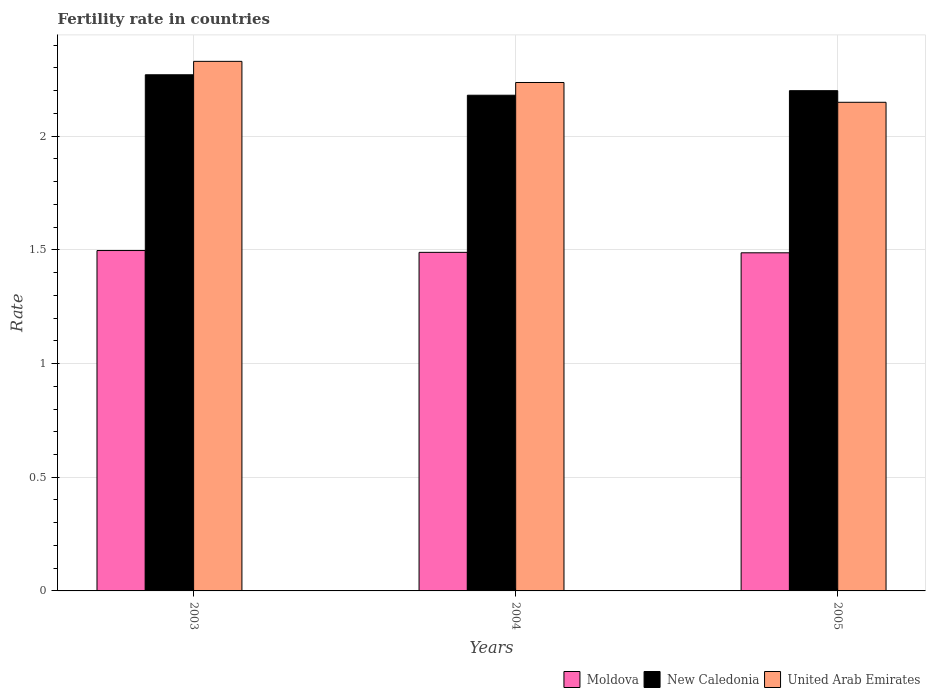Are the number of bars per tick equal to the number of legend labels?
Make the answer very short. Yes. How many bars are there on the 1st tick from the left?
Your answer should be compact. 3. In how many cases, is the number of bars for a given year not equal to the number of legend labels?
Offer a terse response. 0. What is the fertility rate in United Arab Emirates in 2005?
Make the answer very short. 2.15. Across all years, what is the maximum fertility rate in New Caledonia?
Make the answer very short. 2.27. Across all years, what is the minimum fertility rate in Moldova?
Your response must be concise. 1.49. In which year was the fertility rate in Moldova maximum?
Your response must be concise. 2003. In which year was the fertility rate in Moldova minimum?
Your response must be concise. 2005. What is the total fertility rate in United Arab Emirates in the graph?
Your answer should be very brief. 6.71. What is the difference between the fertility rate in New Caledonia in 2004 and that in 2005?
Your response must be concise. -0.02. What is the difference between the fertility rate in United Arab Emirates in 2003 and the fertility rate in Moldova in 2004?
Make the answer very short. 0.84. What is the average fertility rate in Moldova per year?
Provide a short and direct response. 1.49. In the year 2004, what is the difference between the fertility rate in Moldova and fertility rate in United Arab Emirates?
Provide a succinct answer. -0.75. In how many years, is the fertility rate in New Caledonia greater than 2.1?
Ensure brevity in your answer.  3. What is the ratio of the fertility rate in Moldova in 2004 to that in 2005?
Your answer should be very brief. 1. Is the fertility rate in United Arab Emirates in 2003 less than that in 2005?
Your answer should be very brief. No. What is the difference between the highest and the second highest fertility rate in New Caledonia?
Offer a very short reply. 0.07. What is the difference between the highest and the lowest fertility rate in New Caledonia?
Make the answer very short. 0.09. Is the sum of the fertility rate in Moldova in 2004 and 2005 greater than the maximum fertility rate in New Caledonia across all years?
Provide a succinct answer. Yes. What does the 2nd bar from the left in 2005 represents?
Keep it short and to the point. New Caledonia. What does the 3rd bar from the right in 2003 represents?
Make the answer very short. Moldova. What is the difference between two consecutive major ticks on the Y-axis?
Keep it short and to the point. 0.5. Does the graph contain grids?
Give a very brief answer. Yes. Where does the legend appear in the graph?
Give a very brief answer. Bottom right. How many legend labels are there?
Give a very brief answer. 3. What is the title of the graph?
Make the answer very short. Fertility rate in countries. Does "Latin America(all income levels)" appear as one of the legend labels in the graph?
Give a very brief answer. No. What is the label or title of the Y-axis?
Give a very brief answer. Rate. What is the Rate in Moldova in 2003?
Make the answer very short. 1.5. What is the Rate in New Caledonia in 2003?
Ensure brevity in your answer.  2.27. What is the Rate in United Arab Emirates in 2003?
Make the answer very short. 2.33. What is the Rate of Moldova in 2004?
Make the answer very short. 1.49. What is the Rate in New Caledonia in 2004?
Offer a terse response. 2.18. What is the Rate in United Arab Emirates in 2004?
Make the answer very short. 2.24. What is the Rate in Moldova in 2005?
Give a very brief answer. 1.49. What is the Rate of United Arab Emirates in 2005?
Provide a short and direct response. 2.15. Across all years, what is the maximum Rate of Moldova?
Your response must be concise. 1.5. Across all years, what is the maximum Rate of New Caledonia?
Your answer should be compact. 2.27. Across all years, what is the maximum Rate of United Arab Emirates?
Keep it short and to the point. 2.33. Across all years, what is the minimum Rate of Moldova?
Give a very brief answer. 1.49. Across all years, what is the minimum Rate in New Caledonia?
Give a very brief answer. 2.18. Across all years, what is the minimum Rate in United Arab Emirates?
Offer a very short reply. 2.15. What is the total Rate in Moldova in the graph?
Give a very brief answer. 4.47. What is the total Rate in New Caledonia in the graph?
Ensure brevity in your answer.  6.65. What is the total Rate of United Arab Emirates in the graph?
Your response must be concise. 6.71. What is the difference between the Rate in Moldova in 2003 and that in 2004?
Give a very brief answer. 0.01. What is the difference between the Rate in New Caledonia in 2003 and that in 2004?
Provide a short and direct response. 0.09. What is the difference between the Rate in United Arab Emirates in 2003 and that in 2004?
Keep it short and to the point. 0.09. What is the difference between the Rate of New Caledonia in 2003 and that in 2005?
Your response must be concise. 0.07. What is the difference between the Rate of United Arab Emirates in 2003 and that in 2005?
Make the answer very short. 0.18. What is the difference between the Rate in Moldova in 2004 and that in 2005?
Provide a succinct answer. 0. What is the difference between the Rate in New Caledonia in 2004 and that in 2005?
Your answer should be very brief. -0.02. What is the difference between the Rate in United Arab Emirates in 2004 and that in 2005?
Provide a succinct answer. 0.09. What is the difference between the Rate in Moldova in 2003 and the Rate in New Caledonia in 2004?
Provide a short and direct response. -0.68. What is the difference between the Rate in Moldova in 2003 and the Rate in United Arab Emirates in 2004?
Your response must be concise. -0.74. What is the difference between the Rate in New Caledonia in 2003 and the Rate in United Arab Emirates in 2004?
Your answer should be very brief. 0.03. What is the difference between the Rate of Moldova in 2003 and the Rate of New Caledonia in 2005?
Provide a short and direct response. -0.7. What is the difference between the Rate in Moldova in 2003 and the Rate in United Arab Emirates in 2005?
Your answer should be compact. -0.65. What is the difference between the Rate in New Caledonia in 2003 and the Rate in United Arab Emirates in 2005?
Provide a short and direct response. 0.12. What is the difference between the Rate in Moldova in 2004 and the Rate in New Caledonia in 2005?
Provide a succinct answer. -0.71. What is the difference between the Rate of Moldova in 2004 and the Rate of United Arab Emirates in 2005?
Provide a short and direct response. -0.66. What is the difference between the Rate of New Caledonia in 2004 and the Rate of United Arab Emirates in 2005?
Ensure brevity in your answer.  0.03. What is the average Rate in Moldova per year?
Keep it short and to the point. 1.49. What is the average Rate of New Caledonia per year?
Make the answer very short. 2.22. What is the average Rate in United Arab Emirates per year?
Offer a terse response. 2.24. In the year 2003, what is the difference between the Rate of Moldova and Rate of New Caledonia?
Provide a short and direct response. -0.77. In the year 2003, what is the difference between the Rate in Moldova and Rate in United Arab Emirates?
Provide a succinct answer. -0.83. In the year 2003, what is the difference between the Rate of New Caledonia and Rate of United Arab Emirates?
Your answer should be compact. -0.06. In the year 2004, what is the difference between the Rate in Moldova and Rate in New Caledonia?
Offer a very short reply. -0.69. In the year 2004, what is the difference between the Rate of Moldova and Rate of United Arab Emirates?
Provide a short and direct response. -0.75. In the year 2004, what is the difference between the Rate of New Caledonia and Rate of United Arab Emirates?
Offer a terse response. -0.06. In the year 2005, what is the difference between the Rate in Moldova and Rate in New Caledonia?
Make the answer very short. -0.71. In the year 2005, what is the difference between the Rate of Moldova and Rate of United Arab Emirates?
Provide a succinct answer. -0.66. In the year 2005, what is the difference between the Rate of New Caledonia and Rate of United Arab Emirates?
Provide a short and direct response. 0.05. What is the ratio of the Rate of Moldova in 2003 to that in 2004?
Your response must be concise. 1.01. What is the ratio of the Rate of New Caledonia in 2003 to that in 2004?
Ensure brevity in your answer.  1.04. What is the ratio of the Rate in United Arab Emirates in 2003 to that in 2004?
Your answer should be compact. 1.04. What is the ratio of the Rate in Moldova in 2003 to that in 2005?
Provide a short and direct response. 1.01. What is the ratio of the Rate in New Caledonia in 2003 to that in 2005?
Offer a terse response. 1.03. What is the ratio of the Rate of United Arab Emirates in 2003 to that in 2005?
Give a very brief answer. 1.08. What is the ratio of the Rate of Moldova in 2004 to that in 2005?
Your answer should be very brief. 1. What is the ratio of the Rate of New Caledonia in 2004 to that in 2005?
Offer a terse response. 0.99. What is the ratio of the Rate in United Arab Emirates in 2004 to that in 2005?
Offer a very short reply. 1.04. What is the difference between the highest and the second highest Rate of Moldova?
Ensure brevity in your answer.  0.01. What is the difference between the highest and the second highest Rate in New Caledonia?
Make the answer very short. 0.07. What is the difference between the highest and the second highest Rate in United Arab Emirates?
Provide a succinct answer. 0.09. What is the difference between the highest and the lowest Rate in Moldova?
Your response must be concise. 0.01. What is the difference between the highest and the lowest Rate in New Caledonia?
Ensure brevity in your answer.  0.09. What is the difference between the highest and the lowest Rate in United Arab Emirates?
Give a very brief answer. 0.18. 